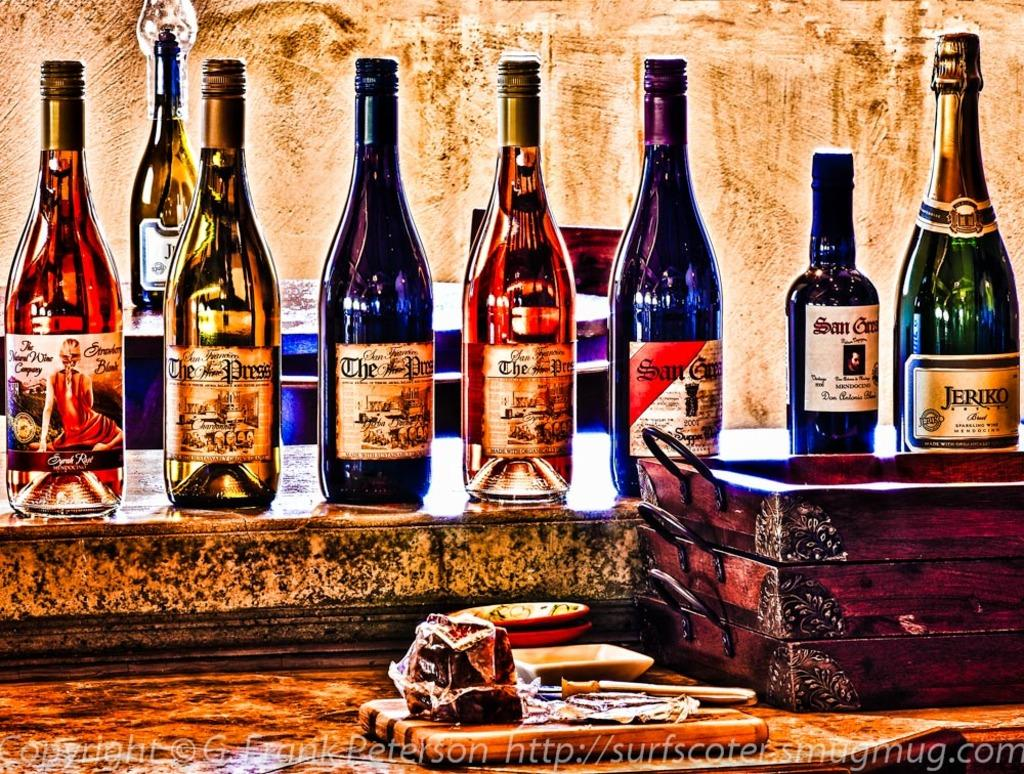<image>
Offer a succinct explanation of the picture presented. A picture of various bottles of alcohol including Jeriko sparkling wine 